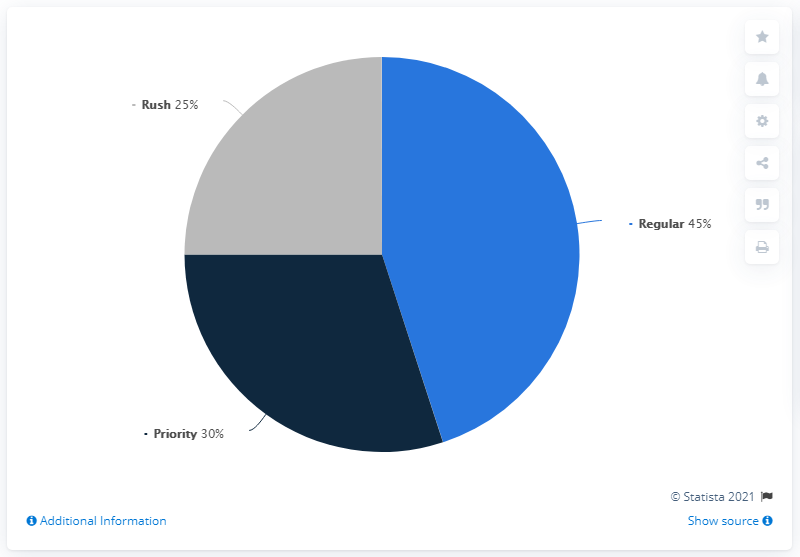Identify some key points in this picture. In 2018, priority service accounted for approximately 30% of the same-day delivery market. The segment that occupies more than half of the pie chart is "Regular. The survey found that there is a ratio of 1.8 between the most preferred and the least preferred delivery services. 